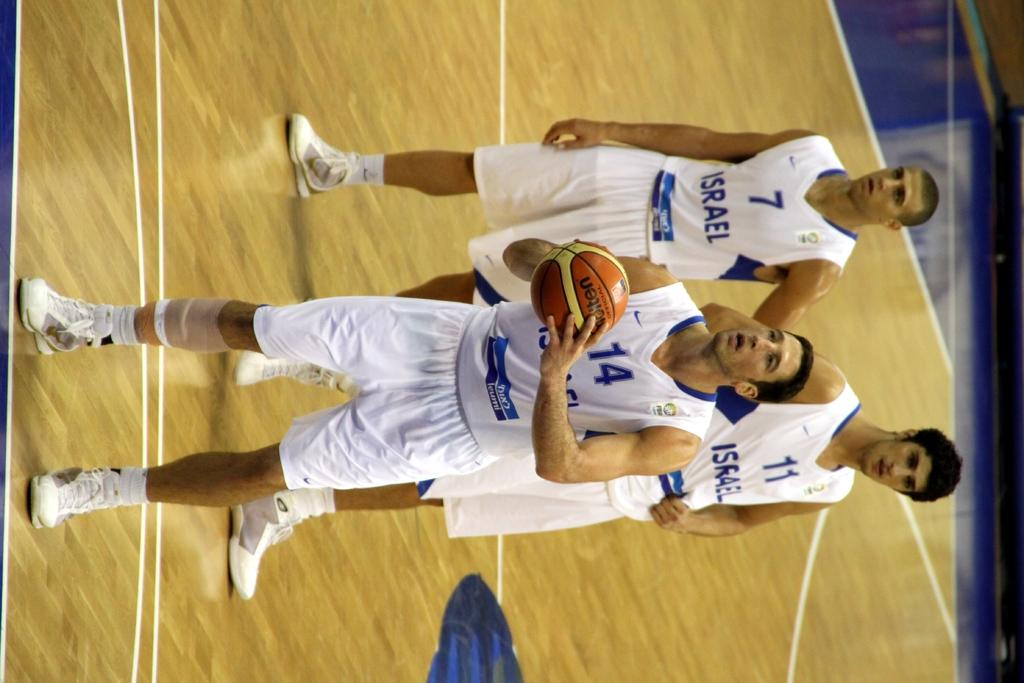<image>
Describe the image concisely. A basket ball team wearing a jersey that says Israel on the jersey. 